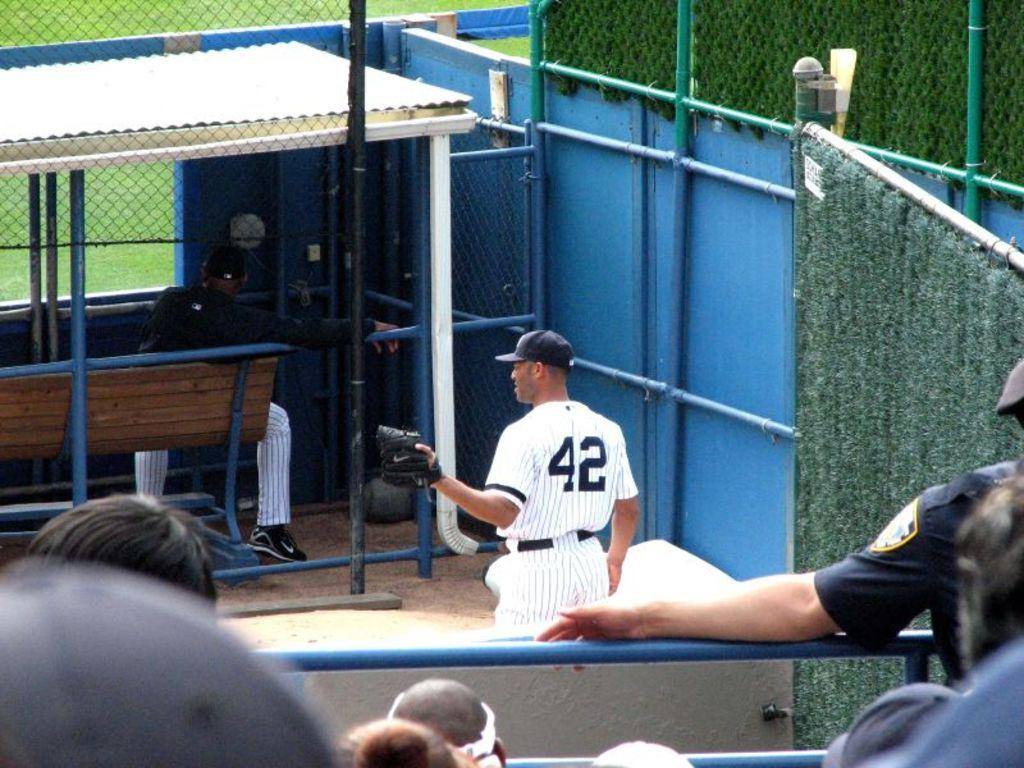Provide a one-sentence caption for the provided image. A baseball player with the jersey 42 stepping out the dugout. 